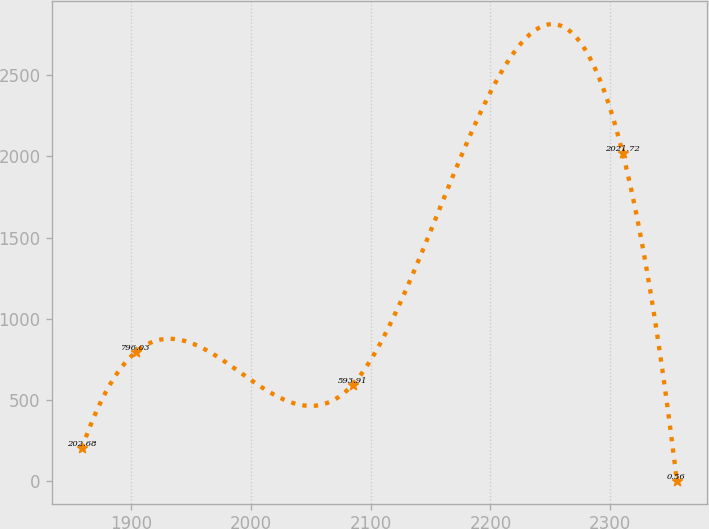<chart> <loc_0><loc_0><loc_500><loc_500><line_chart><ecel><fcel>Unnamed: 1<nl><fcel>1858.84<fcel>202.68<nl><fcel>1904.09<fcel>796.03<nl><fcel>2085.01<fcel>593.91<nl><fcel>2310.37<fcel>2021.72<nl><fcel>2355.62<fcel>0.56<nl></chart> 